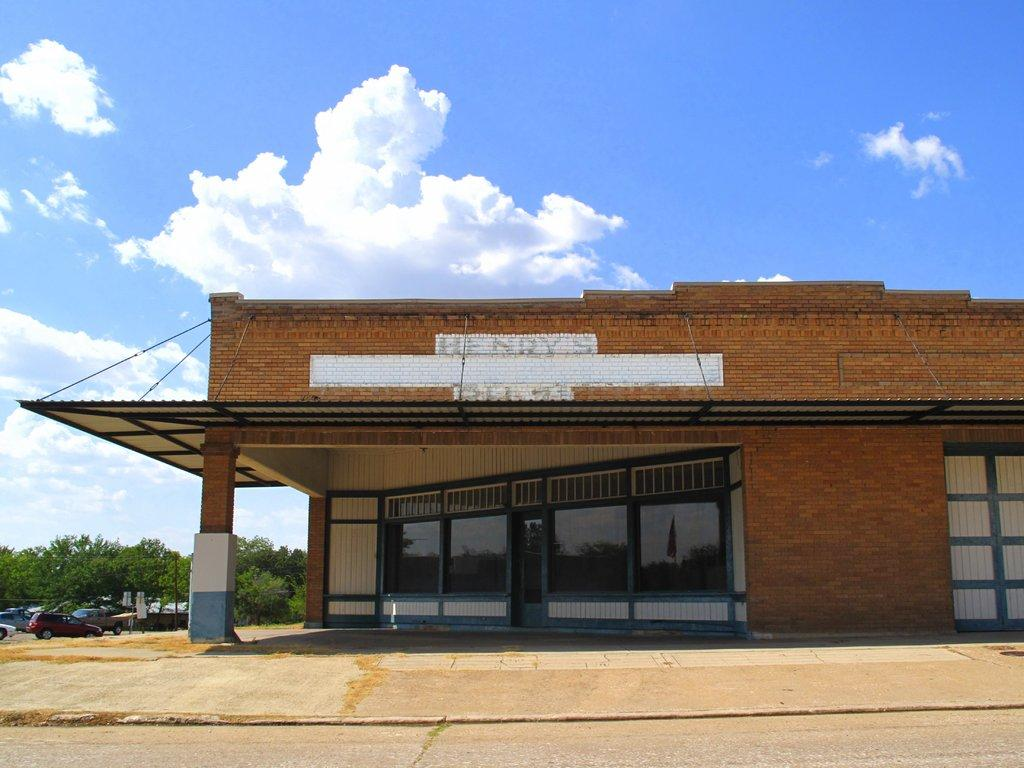What type of surface can be seen in the image? There is a road in the image. What type of structures are present in the image? There are brick buildings in the image. What type of windows can be seen on the buildings? There are glass windows in the image. What can be seen parked along the road? Vehicles are parked in the image. What type of vegetation is present in the image? There are trees in the image. What color is the sky in the background? The sky in the background is blue. Where can the cakes be found in the image? There are no cakes present in the image. What type of toothpaste is used to clean the windows in the image? There is no toothpaste mentioned or implied in the image; the windows are made of glass. 